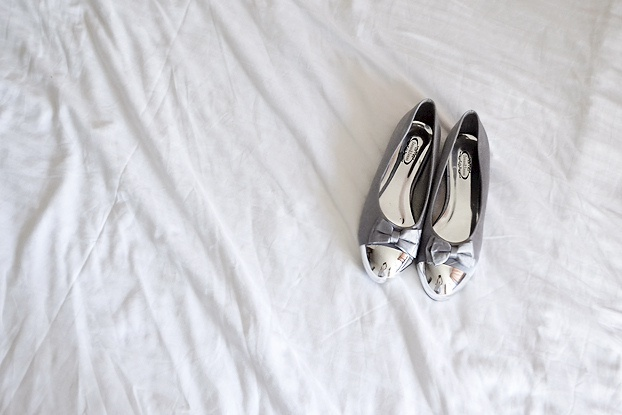Describe the objects in this image and their specific colors. I can see a bed in lightgray, darkgray, and gray tones in this image. 